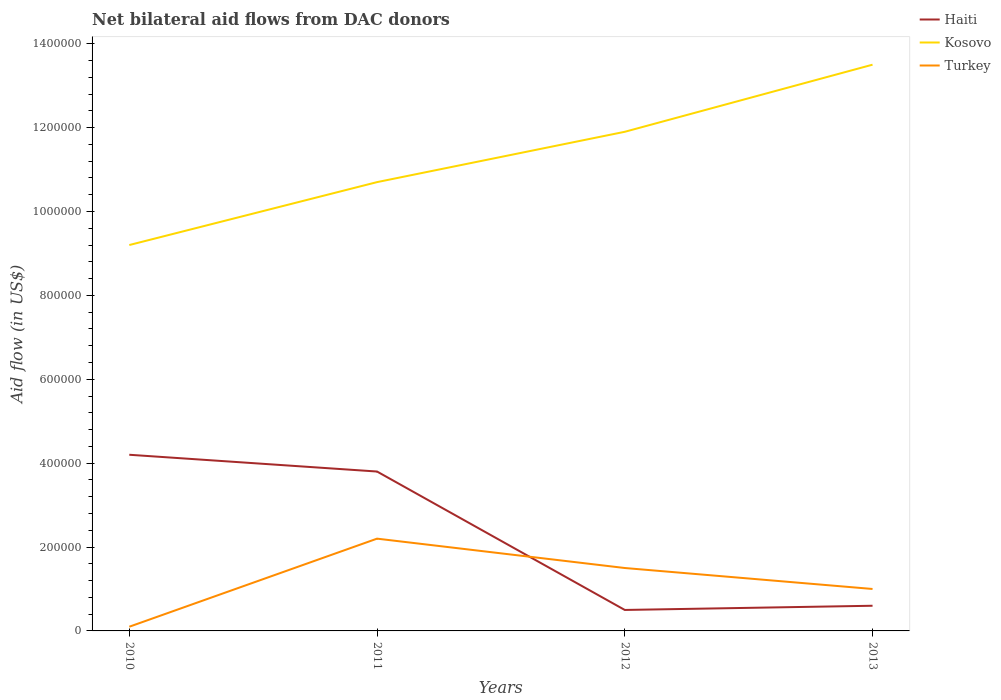Does the line corresponding to Kosovo intersect with the line corresponding to Haiti?
Your answer should be very brief. No. Across all years, what is the maximum net bilateral aid flow in Kosovo?
Your answer should be compact. 9.20e+05. What is the total net bilateral aid flow in Turkey in the graph?
Provide a short and direct response. 7.00e+04. What is the difference between the highest and the second highest net bilateral aid flow in Haiti?
Your answer should be very brief. 3.70e+05. How many lines are there?
Provide a succinct answer. 3. What is the difference between two consecutive major ticks on the Y-axis?
Your answer should be very brief. 2.00e+05. Does the graph contain any zero values?
Provide a short and direct response. No. Does the graph contain grids?
Offer a very short reply. No. How are the legend labels stacked?
Keep it short and to the point. Vertical. What is the title of the graph?
Provide a succinct answer. Net bilateral aid flows from DAC donors. What is the label or title of the X-axis?
Provide a succinct answer. Years. What is the label or title of the Y-axis?
Make the answer very short. Aid flow (in US$). What is the Aid flow (in US$) of Haiti in 2010?
Your answer should be compact. 4.20e+05. What is the Aid flow (in US$) of Kosovo in 2010?
Provide a succinct answer. 9.20e+05. What is the Aid flow (in US$) of Kosovo in 2011?
Ensure brevity in your answer.  1.07e+06. What is the Aid flow (in US$) in Turkey in 2011?
Make the answer very short. 2.20e+05. What is the Aid flow (in US$) of Kosovo in 2012?
Ensure brevity in your answer.  1.19e+06. What is the Aid flow (in US$) of Haiti in 2013?
Make the answer very short. 6.00e+04. What is the Aid flow (in US$) in Kosovo in 2013?
Give a very brief answer. 1.35e+06. Across all years, what is the maximum Aid flow (in US$) of Haiti?
Keep it short and to the point. 4.20e+05. Across all years, what is the maximum Aid flow (in US$) in Kosovo?
Your response must be concise. 1.35e+06. Across all years, what is the maximum Aid flow (in US$) in Turkey?
Make the answer very short. 2.20e+05. Across all years, what is the minimum Aid flow (in US$) of Haiti?
Make the answer very short. 5.00e+04. Across all years, what is the minimum Aid flow (in US$) in Kosovo?
Make the answer very short. 9.20e+05. Across all years, what is the minimum Aid flow (in US$) in Turkey?
Offer a terse response. 10000. What is the total Aid flow (in US$) of Haiti in the graph?
Provide a succinct answer. 9.10e+05. What is the total Aid flow (in US$) in Kosovo in the graph?
Provide a succinct answer. 4.53e+06. What is the total Aid flow (in US$) of Turkey in the graph?
Offer a very short reply. 4.80e+05. What is the difference between the Aid flow (in US$) in Haiti in 2010 and that in 2011?
Ensure brevity in your answer.  4.00e+04. What is the difference between the Aid flow (in US$) in Kosovo in 2010 and that in 2011?
Give a very brief answer. -1.50e+05. What is the difference between the Aid flow (in US$) in Haiti in 2010 and that in 2012?
Your response must be concise. 3.70e+05. What is the difference between the Aid flow (in US$) of Haiti in 2010 and that in 2013?
Provide a short and direct response. 3.60e+05. What is the difference between the Aid flow (in US$) in Kosovo in 2010 and that in 2013?
Provide a succinct answer. -4.30e+05. What is the difference between the Aid flow (in US$) of Turkey in 2010 and that in 2013?
Offer a terse response. -9.00e+04. What is the difference between the Aid flow (in US$) of Haiti in 2011 and that in 2012?
Offer a very short reply. 3.30e+05. What is the difference between the Aid flow (in US$) of Kosovo in 2011 and that in 2012?
Your answer should be compact. -1.20e+05. What is the difference between the Aid flow (in US$) of Turkey in 2011 and that in 2012?
Your answer should be compact. 7.00e+04. What is the difference between the Aid flow (in US$) of Haiti in 2011 and that in 2013?
Keep it short and to the point. 3.20e+05. What is the difference between the Aid flow (in US$) of Kosovo in 2011 and that in 2013?
Provide a short and direct response. -2.80e+05. What is the difference between the Aid flow (in US$) of Turkey in 2012 and that in 2013?
Your answer should be very brief. 5.00e+04. What is the difference between the Aid flow (in US$) in Haiti in 2010 and the Aid flow (in US$) in Kosovo in 2011?
Your answer should be very brief. -6.50e+05. What is the difference between the Aid flow (in US$) in Kosovo in 2010 and the Aid flow (in US$) in Turkey in 2011?
Make the answer very short. 7.00e+05. What is the difference between the Aid flow (in US$) of Haiti in 2010 and the Aid flow (in US$) of Kosovo in 2012?
Offer a terse response. -7.70e+05. What is the difference between the Aid flow (in US$) in Kosovo in 2010 and the Aid flow (in US$) in Turkey in 2012?
Your answer should be compact. 7.70e+05. What is the difference between the Aid flow (in US$) of Haiti in 2010 and the Aid flow (in US$) of Kosovo in 2013?
Offer a very short reply. -9.30e+05. What is the difference between the Aid flow (in US$) of Haiti in 2010 and the Aid flow (in US$) of Turkey in 2013?
Your answer should be very brief. 3.20e+05. What is the difference between the Aid flow (in US$) of Kosovo in 2010 and the Aid flow (in US$) of Turkey in 2013?
Provide a succinct answer. 8.20e+05. What is the difference between the Aid flow (in US$) in Haiti in 2011 and the Aid flow (in US$) in Kosovo in 2012?
Offer a terse response. -8.10e+05. What is the difference between the Aid flow (in US$) in Kosovo in 2011 and the Aid flow (in US$) in Turkey in 2012?
Give a very brief answer. 9.20e+05. What is the difference between the Aid flow (in US$) of Haiti in 2011 and the Aid flow (in US$) of Kosovo in 2013?
Your response must be concise. -9.70e+05. What is the difference between the Aid flow (in US$) in Haiti in 2011 and the Aid flow (in US$) in Turkey in 2013?
Provide a succinct answer. 2.80e+05. What is the difference between the Aid flow (in US$) in Kosovo in 2011 and the Aid flow (in US$) in Turkey in 2013?
Provide a short and direct response. 9.70e+05. What is the difference between the Aid flow (in US$) in Haiti in 2012 and the Aid flow (in US$) in Kosovo in 2013?
Your answer should be very brief. -1.30e+06. What is the difference between the Aid flow (in US$) of Haiti in 2012 and the Aid flow (in US$) of Turkey in 2013?
Make the answer very short. -5.00e+04. What is the difference between the Aid flow (in US$) in Kosovo in 2012 and the Aid flow (in US$) in Turkey in 2013?
Your answer should be very brief. 1.09e+06. What is the average Aid flow (in US$) in Haiti per year?
Your answer should be compact. 2.28e+05. What is the average Aid flow (in US$) of Kosovo per year?
Your answer should be very brief. 1.13e+06. In the year 2010, what is the difference between the Aid flow (in US$) of Haiti and Aid flow (in US$) of Kosovo?
Offer a very short reply. -5.00e+05. In the year 2010, what is the difference between the Aid flow (in US$) in Haiti and Aid flow (in US$) in Turkey?
Your response must be concise. 4.10e+05. In the year 2010, what is the difference between the Aid flow (in US$) of Kosovo and Aid flow (in US$) of Turkey?
Your answer should be compact. 9.10e+05. In the year 2011, what is the difference between the Aid flow (in US$) in Haiti and Aid flow (in US$) in Kosovo?
Provide a short and direct response. -6.90e+05. In the year 2011, what is the difference between the Aid flow (in US$) in Haiti and Aid flow (in US$) in Turkey?
Give a very brief answer. 1.60e+05. In the year 2011, what is the difference between the Aid flow (in US$) of Kosovo and Aid flow (in US$) of Turkey?
Provide a short and direct response. 8.50e+05. In the year 2012, what is the difference between the Aid flow (in US$) in Haiti and Aid flow (in US$) in Kosovo?
Offer a terse response. -1.14e+06. In the year 2012, what is the difference between the Aid flow (in US$) of Haiti and Aid flow (in US$) of Turkey?
Your response must be concise. -1.00e+05. In the year 2012, what is the difference between the Aid flow (in US$) of Kosovo and Aid flow (in US$) of Turkey?
Offer a very short reply. 1.04e+06. In the year 2013, what is the difference between the Aid flow (in US$) of Haiti and Aid flow (in US$) of Kosovo?
Offer a terse response. -1.29e+06. In the year 2013, what is the difference between the Aid flow (in US$) of Haiti and Aid flow (in US$) of Turkey?
Ensure brevity in your answer.  -4.00e+04. In the year 2013, what is the difference between the Aid flow (in US$) of Kosovo and Aid flow (in US$) of Turkey?
Your answer should be very brief. 1.25e+06. What is the ratio of the Aid flow (in US$) in Haiti in 2010 to that in 2011?
Offer a very short reply. 1.11. What is the ratio of the Aid flow (in US$) of Kosovo in 2010 to that in 2011?
Ensure brevity in your answer.  0.86. What is the ratio of the Aid flow (in US$) in Turkey in 2010 to that in 2011?
Your answer should be compact. 0.05. What is the ratio of the Aid flow (in US$) in Haiti in 2010 to that in 2012?
Your answer should be very brief. 8.4. What is the ratio of the Aid flow (in US$) of Kosovo in 2010 to that in 2012?
Your answer should be compact. 0.77. What is the ratio of the Aid flow (in US$) in Turkey in 2010 to that in 2012?
Make the answer very short. 0.07. What is the ratio of the Aid flow (in US$) of Kosovo in 2010 to that in 2013?
Your answer should be very brief. 0.68. What is the ratio of the Aid flow (in US$) in Haiti in 2011 to that in 2012?
Provide a succinct answer. 7.6. What is the ratio of the Aid flow (in US$) of Kosovo in 2011 to that in 2012?
Offer a terse response. 0.9. What is the ratio of the Aid flow (in US$) in Turkey in 2011 to that in 2012?
Your answer should be compact. 1.47. What is the ratio of the Aid flow (in US$) in Haiti in 2011 to that in 2013?
Your response must be concise. 6.33. What is the ratio of the Aid flow (in US$) in Kosovo in 2011 to that in 2013?
Give a very brief answer. 0.79. What is the ratio of the Aid flow (in US$) in Haiti in 2012 to that in 2013?
Your answer should be very brief. 0.83. What is the ratio of the Aid flow (in US$) in Kosovo in 2012 to that in 2013?
Your answer should be very brief. 0.88. What is the ratio of the Aid flow (in US$) of Turkey in 2012 to that in 2013?
Provide a succinct answer. 1.5. What is the difference between the highest and the second highest Aid flow (in US$) of Haiti?
Make the answer very short. 4.00e+04. What is the difference between the highest and the second highest Aid flow (in US$) of Kosovo?
Give a very brief answer. 1.60e+05. What is the difference between the highest and the second highest Aid flow (in US$) of Turkey?
Make the answer very short. 7.00e+04. What is the difference between the highest and the lowest Aid flow (in US$) of Kosovo?
Keep it short and to the point. 4.30e+05. What is the difference between the highest and the lowest Aid flow (in US$) of Turkey?
Offer a very short reply. 2.10e+05. 